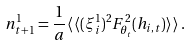<formula> <loc_0><loc_0><loc_500><loc_500>n ^ { 1 } _ { t + 1 } = \frac { 1 } { a } \langle \, \langle ( \xi _ { i } ^ { 1 } ) ^ { 2 } F _ { \theta _ { t } } ^ { 2 } ( h _ { i , t } ) \rangle \, \rangle \, .</formula> 